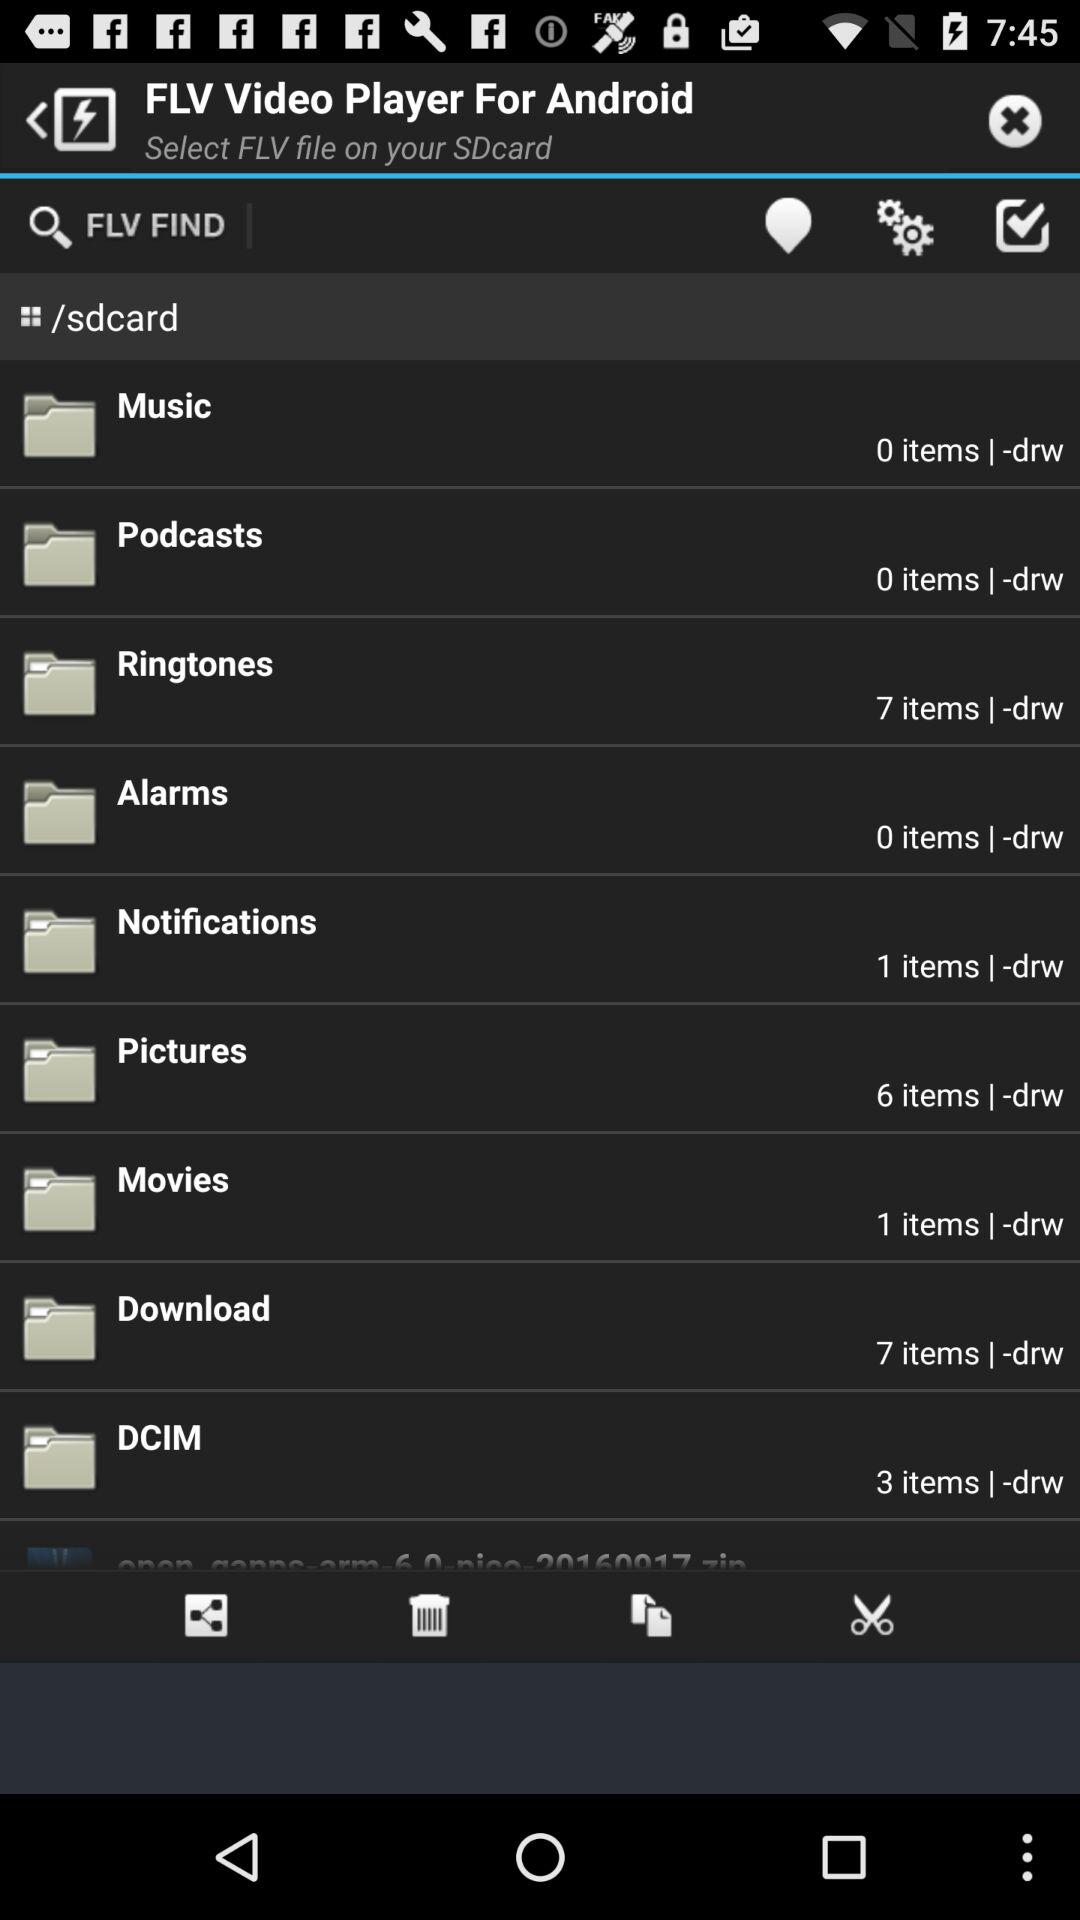How many items does a DCIM folder hold? A DCIM folder holds 3 items. 